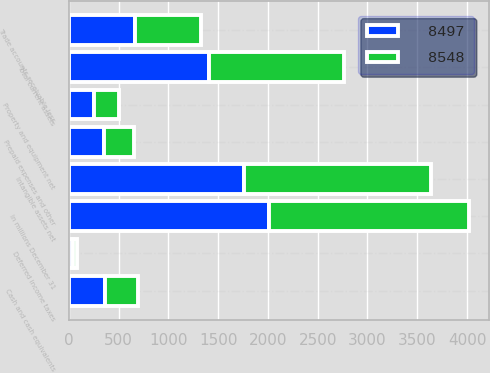Convert chart to OTSL. <chart><loc_0><loc_0><loc_500><loc_500><stacked_bar_chart><ecel><fcel>In millions December 31<fcel>Cash and cash equivalents<fcel>Trade accounts receivable less<fcel>Deferred income taxes<fcel>Prepaid expenses and other<fcel>Total current assets<fcel>Property and equipment net<fcel>Intangible assets net<nl><fcel>8497<fcel>2012<fcel>358<fcel>663<fcel>42<fcel>349<fcel>1412<fcel>249<fcel>1760<nl><fcel>8548<fcel>2011<fcel>337<fcel>666<fcel>44<fcel>309<fcel>1356<fcel>258<fcel>1881<nl></chart> 